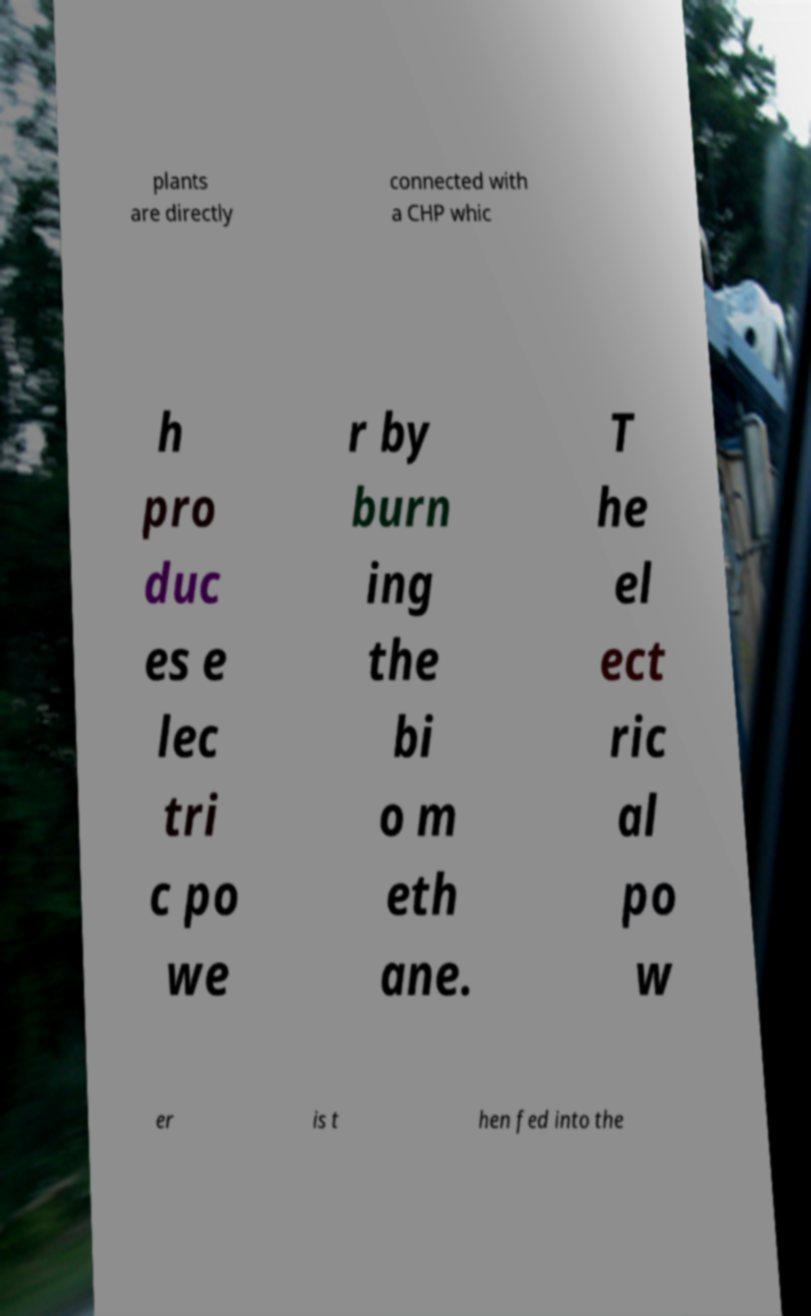Can you accurately transcribe the text from the provided image for me? plants are directly connected with a CHP whic h pro duc es e lec tri c po we r by burn ing the bi o m eth ane. T he el ect ric al po w er is t hen fed into the 